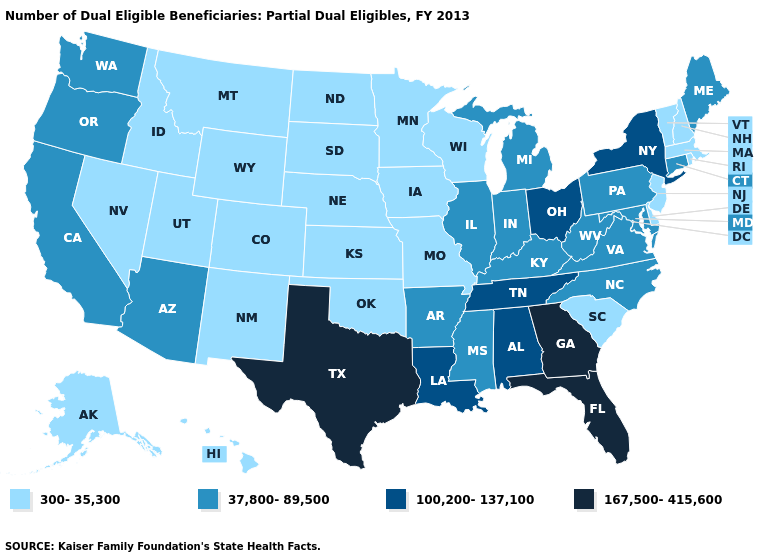Among the states that border Missouri , does Arkansas have the lowest value?
Be succinct. No. What is the value of Michigan?
Short answer required. 37,800-89,500. Which states have the lowest value in the Northeast?
Give a very brief answer. Massachusetts, New Hampshire, New Jersey, Rhode Island, Vermont. What is the value of Nevada?
Concise answer only. 300-35,300. Does Maine have a lower value than Tennessee?
Concise answer only. Yes. What is the value of South Dakota?
Concise answer only. 300-35,300. What is the value of Ohio?
Keep it brief. 100,200-137,100. Among the states that border New York , which have the highest value?
Keep it brief. Connecticut, Pennsylvania. Does New Jersey have the highest value in the Northeast?
Answer briefly. No. Does the map have missing data?
Quick response, please. No. What is the highest value in the Northeast ?
Write a very short answer. 100,200-137,100. Does Delaware have a higher value than Montana?
Quick response, please. No. What is the highest value in the South ?
Give a very brief answer. 167,500-415,600. Does South Carolina have the lowest value in the USA?
Quick response, please. Yes. Does Idaho have the same value as Kentucky?
Be succinct. No. 